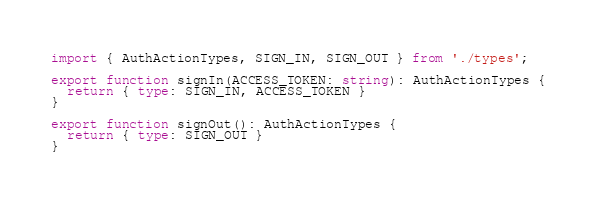Convert code to text. <code><loc_0><loc_0><loc_500><loc_500><_TypeScript_>import { AuthActionTypes, SIGN_IN, SIGN_OUT } from './types';

export function signIn(ACCESS_TOKEN: string): AuthActionTypes {
  return { type: SIGN_IN, ACCESS_TOKEN }
}

export function signOut(): AuthActionTypes {
  return { type: SIGN_OUT }
}</code> 